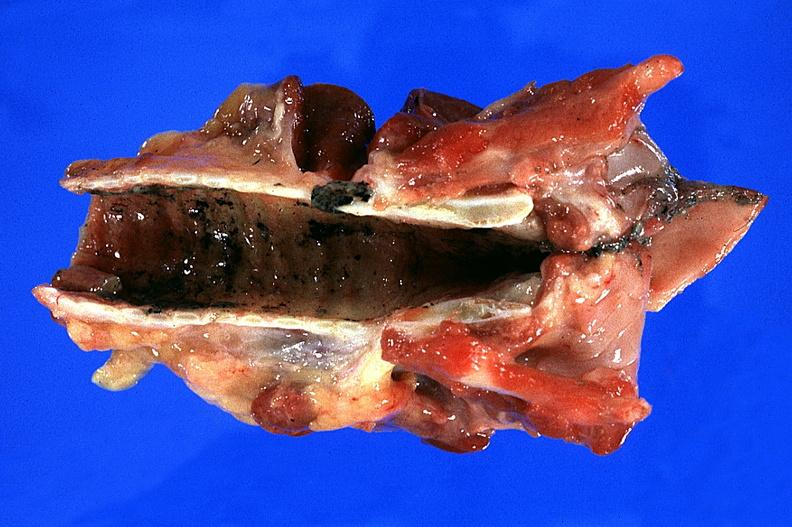s respiratory present?
Answer the question using a single word or phrase. Yes 